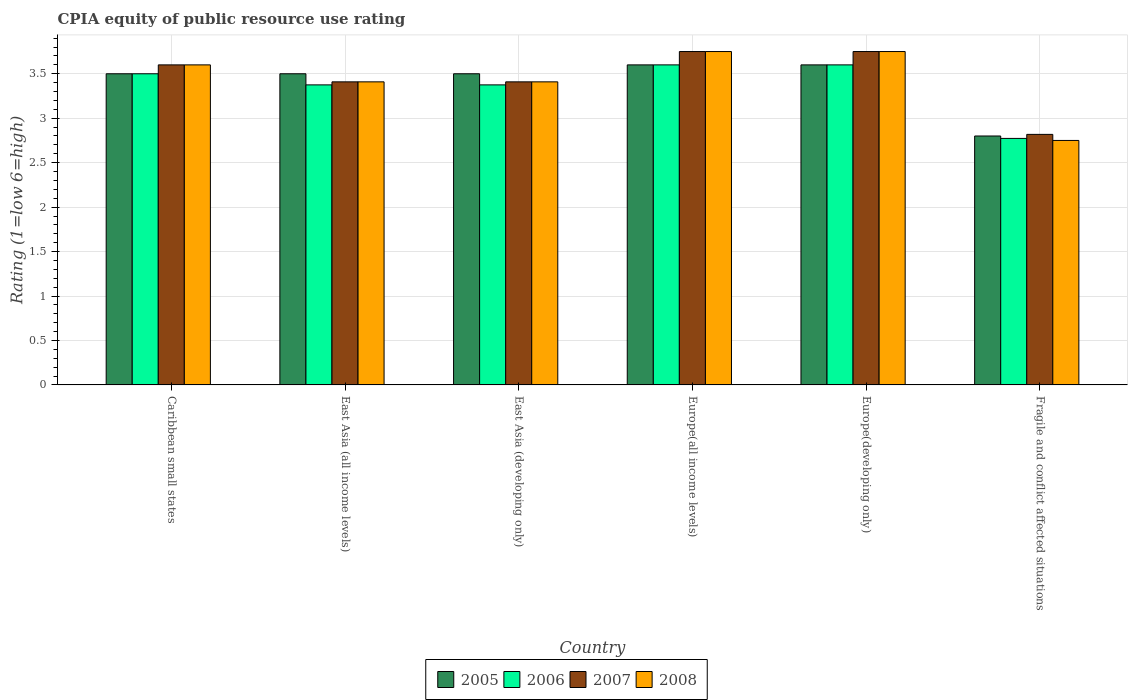How many different coloured bars are there?
Ensure brevity in your answer.  4. How many groups of bars are there?
Your answer should be compact. 6. What is the label of the 6th group of bars from the left?
Provide a succinct answer. Fragile and conflict affected situations. What is the CPIA rating in 2006 in Europe(all income levels)?
Your answer should be compact. 3.6. Across all countries, what is the maximum CPIA rating in 2008?
Your answer should be very brief. 3.75. In which country was the CPIA rating in 2007 maximum?
Your response must be concise. Europe(all income levels). In which country was the CPIA rating in 2007 minimum?
Your answer should be compact. Fragile and conflict affected situations. What is the total CPIA rating in 2008 in the graph?
Keep it short and to the point. 20.67. What is the difference between the CPIA rating in 2008 in Caribbean small states and that in Fragile and conflict affected situations?
Offer a terse response. 0.85. What is the difference between the CPIA rating in 2008 in Caribbean small states and the CPIA rating in 2006 in Europe(all income levels)?
Your answer should be compact. 0. What is the average CPIA rating in 2007 per country?
Make the answer very short. 3.46. What is the difference between the CPIA rating of/in 2005 and CPIA rating of/in 2007 in Europe(developing only)?
Make the answer very short. -0.15. What is the ratio of the CPIA rating in 2006 in Europe(developing only) to that in Fragile and conflict affected situations?
Offer a terse response. 1.3. Is the difference between the CPIA rating in 2005 in Europe(all income levels) and Fragile and conflict affected situations greater than the difference between the CPIA rating in 2007 in Europe(all income levels) and Fragile and conflict affected situations?
Offer a terse response. No. What is the difference between the highest and the second highest CPIA rating in 2006?
Provide a succinct answer. -0.1. What is the difference between the highest and the lowest CPIA rating in 2005?
Provide a short and direct response. 0.8. What does the 4th bar from the right in East Asia (all income levels) represents?
Give a very brief answer. 2005. How many countries are there in the graph?
Your answer should be very brief. 6. What is the difference between two consecutive major ticks on the Y-axis?
Keep it short and to the point. 0.5. Are the values on the major ticks of Y-axis written in scientific E-notation?
Provide a short and direct response. No. Where does the legend appear in the graph?
Provide a succinct answer. Bottom center. What is the title of the graph?
Provide a succinct answer. CPIA equity of public resource use rating. Does "2013" appear as one of the legend labels in the graph?
Offer a very short reply. No. What is the label or title of the X-axis?
Ensure brevity in your answer.  Country. What is the label or title of the Y-axis?
Offer a terse response. Rating (1=low 6=high). What is the Rating (1=low 6=high) in 2008 in Caribbean small states?
Your answer should be very brief. 3.6. What is the Rating (1=low 6=high) of 2005 in East Asia (all income levels)?
Provide a short and direct response. 3.5. What is the Rating (1=low 6=high) of 2006 in East Asia (all income levels)?
Your response must be concise. 3.38. What is the Rating (1=low 6=high) of 2007 in East Asia (all income levels)?
Your answer should be very brief. 3.41. What is the Rating (1=low 6=high) in 2008 in East Asia (all income levels)?
Make the answer very short. 3.41. What is the Rating (1=low 6=high) of 2005 in East Asia (developing only)?
Your answer should be compact. 3.5. What is the Rating (1=low 6=high) of 2006 in East Asia (developing only)?
Offer a very short reply. 3.38. What is the Rating (1=low 6=high) of 2007 in East Asia (developing only)?
Your answer should be very brief. 3.41. What is the Rating (1=low 6=high) in 2008 in East Asia (developing only)?
Your answer should be very brief. 3.41. What is the Rating (1=low 6=high) in 2007 in Europe(all income levels)?
Keep it short and to the point. 3.75. What is the Rating (1=low 6=high) of 2008 in Europe(all income levels)?
Your answer should be very brief. 3.75. What is the Rating (1=low 6=high) of 2006 in Europe(developing only)?
Give a very brief answer. 3.6. What is the Rating (1=low 6=high) in 2007 in Europe(developing only)?
Provide a succinct answer. 3.75. What is the Rating (1=low 6=high) in 2008 in Europe(developing only)?
Your response must be concise. 3.75. What is the Rating (1=low 6=high) in 2006 in Fragile and conflict affected situations?
Your answer should be very brief. 2.77. What is the Rating (1=low 6=high) of 2007 in Fragile and conflict affected situations?
Ensure brevity in your answer.  2.82. What is the Rating (1=low 6=high) of 2008 in Fragile and conflict affected situations?
Make the answer very short. 2.75. Across all countries, what is the maximum Rating (1=low 6=high) in 2005?
Your answer should be very brief. 3.6. Across all countries, what is the maximum Rating (1=low 6=high) in 2007?
Offer a terse response. 3.75. Across all countries, what is the maximum Rating (1=low 6=high) in 2008?
Offer a very short reply. 3.75. Across all countries, what is the minimum Rating (1=low 6=high) of 2006?
Ensure brevity in your answer.  2.77. Across all countries, what is the minimum Rating (1=low 6=high) of 2007?
Keep it short and to the point. 2.82. Across all countries, what is the minimum Rating (1=low 6=high) of 2008?
Offer a terse response. 2.75. What is the total Rating (1=low 6=high) in 2005 in the graph?
Your answer should be compact. 20.5. What is the total Rating (1=low 6=high) in 2006 in the graph?
Your response must be concise. 20.22. What is the total Rating (1=low 6=high) of 2007 in the graph?
Make the answer very short. 20.74. What is the total Rating (1=low 6=high) in 2008 in the graph?
Provide a succinct answer. 20.67. What is the difference between the Rating (1=low 6=high) in 2005 in Caribbean small states and that in East Asia (all income levels)?
Your response must be concise. 0. What is the difference between the Rating (1=low 6=high) in 2007 in Caribbean small states and that in East Asia (all income levels)?
Offer a terse response. 0.19. What is the difference between the Rating (1=low 6=high) in 2008 in Caribbean small states and that in East Asia (all income levels)?
Provide a short and direct response. 0.19. What is the difference between the Rating (1=low 6=high) of 2005 in Caribbean small states and that in East Asia (developing only)?
Provide a short and direct response. 0. What is the difference between the Rating (1=low 6=high) in 2006 in Caribbean small states and that in East Asia (developing only)?
Give a very brief answer. 0.12. What is the difference between the Rating (1=low 6=high) of 2007 in Caribbean small states and that in East Asia (developing only)?
Offer a very short reply. 0.19. What is the difference between the Rating (1=low 6=high) in 2008 in Caribbean small states and that in East Asia (developing only)?
Provide a short and direct response. 0.19. What is the difference between the Rating (1=low 6=high) in 2006 in Caribbean small states and that in Europe(all income levels)?
Provide a short and direct response. -0.1. What is the difference between the Rating (1=low 6=high) in 2006 in Caribbean small states and that in Europe(developing only)?
Offer a terse response. -0.1. What is the difference between the Rating (1=low 6=high) of 2007 in Caribbean small states and that in Europe(developing only)?
Make the answer very short. -0.15. What is the difference between the Rating (1=low 6=high) in 2006 in Caribbean small states and that in Fragile and conflict affected situations?
Provide a succinct answer. 0.73. What is the difference between the Rating (1=low 6=high) in 2007 in Caribbean small states and that in Fragile and conflict affected situations?
Provide a short and direct response. 0.78. What is the difference between the Rating (1=low 6=high) in 2008 in Caribbean small states and that in Fragile and conflict affected situations?
Your answer should be very brief. 0.85. What is the difference between the Rating (1=low 6=high) in 2005 in East Asia (all income levels) and that in East Asia (developing only)?
Provide a short and direct response. 0. What is the difference between the Rating (1=low 6=high) in 2007 in East Asia (all income levels) and that in East Asia (developing only)?
Ensure brevity in your answer.  0. What is the difference between the Rating (1=low 6=high) in 2006 in East Asia (all income levels) and that in Europe(all income levels)?
Provide a succinct answer. -0.23. What is the difference between the Rating (1=low 6=high) of 2007 in East Asia (all income levels) and that in Europe(all income levels)?
Offer a terse response. -0.34. What is the difference between the Rating (1=low 6=high) in 2008 in East Asia (all income levels) and that in Europe(all income levels)?
Keep it short and to the point. -0.34. What is the difference between the Rating (1=low 6=high) of 2006 in East Asia (all income levels) and that in Europe(developing only)?
Ensure brevity in your answer.  -0.23. What is the difference between the Rating (1=low 6=high) of 2007 in East Asia (all income levels) and that in Europe(developing only)?
Offer a very short reply. -0.34. What is the difference between the Rating (1=low 6=high) in 2008 in East Asia (all income levels) and that in Europe(developing only)?
Offer a very short reply. -0.34. What is the difference between the Rating (1=low 6=high) in 2005 in East Asia (all income levels) and that in Fragile and conflict affected situations?
Keep it short and to the point. 0.7. What is the difference between the Rating (1=low 6=high) in 2006 in East Asia (all income levels) and that in Fragile and conflict affected situations?
Make the answer very short. 0.6. What is the difference between the Rating (1=low 6=high) in 2007 in East Asia (all income levels) and that in Fragile and conflict affected situations?
Keep it short and to the point. 0.59. What is the difference between the Rating (1=low 6=high) of 2008 in East Asia (all income levels) and that in Fragile and conflict affected situations?
Provide a succinct answer. 0.66. What is the difference between the Rating (1=low 6=high) in 2005 in East Asia (developing only) and that in Europe(all income levels)?
Offer a terse response. -0.1. What is the difference between the Rating (1=low 6=high) in 2006 in East Asia (developing only) and that in Europe(all income levels)?
Ensure brevity in your answer.  -0.23. What is the difference between the Rating (1=low 6=high) of 2007 in East Asia (developing only) and that in Europe(all income levels)?
Offer a very short reply. -0.34. What is the difference between the Rating (1=low 6=high) in 2008 in East Asia (developing only) and that in Europe(all income levels)?
Offer a very short reply. -0.34. What is the difference between the Rating (1=low 6=high) in 2006 in East Asia (developing only) and that in Europe(developing only)?
Provide a short and direct response. -0.23. What is the difference between the Rating (1=low 6=high) of 2007 in East Asia (developing only) and that in Europe(developing only)?
Give a very brief answer. -0.34. What is the difference between the Rating (1=low 6=high) in 2008 in East Asia (developing only) and that in Europe(developing only)?
Keep it short and to the point. -0.34. What is the difference between the Rating (1=low 6=high) in 2005 in East Asia (developing only) and that in Fragile and conflict affected situations?
Your response must be concise. 0.7. What is the difference between the Rating (1=low 6=high) of 2006 in East Asia (developing only) and that in Fragile and conflict affected situations?
Give a very brief answer. 0.6. What is the difference between the Rating (1=low 6=high) in 2007 in East Asia (developing only) and that in Fragile and conflict affected situations?
Offer a very short reply. 0.59. What is the difference between the Rating (1=low 6=high) of 2008 in East Asia (developing only) and that in Fragile and conflict affected situations?
Provide a succinct answer. 0.66. What is the difference between the Rating (1=low 6=high) in 2005 in Europe(all income levels) and that in Europe(developing only)?
Give a very brief answer. 0. What is the difference between the Rating (1=low 6=high) in 2006 in Europe(all income levels) and that in Europe(developing only)?
Keep it short and to the point. 0. What is the difference between the Rating (1=low 6=high) in 2007 in Europe(all income levels) and that in Europe(developing only)?
Provide a short and direct response. 0. What is the difference between the Rating (1=low 6=high) in 2008 in Europe(all income levels) and that in Europe(developing only)?
Your answer should be compact. 0. What is the difference between the Rating (1=low 6=high) in 2006 in Europe(all income levels) and that in Fragile and conflict affected situations?
Provide a short and direct response. 0.83. What is the difference between the Rating (1=low 6=high) in 2007 in Europe(all income levels) and that in Fragile and conflict affected situations?
Provide a succinct answer. 0.93. What is the difference between the Rating (1=low 6=high) in 2008 in Europe(all income levels) and that in Fragile and conflict affected situations?
Keep it short and to the point. 1. What is the difference between the Rating (1=low 6=high) of 2005 in Europe(developing only) and that in Fragile and conflict affected situations?
Offer a very short reply. 0.8. What is the difference between the Rating (1=low 6=high) in 2006 in Europe(developing only) and that in Fragile and conflict affected situations?
Ensure brevity in your answer.  0.83. What is the difference between the Rating (1=low 6=high) of 2007 in Europe(developing only) and that in Fragile and conflict affected situations?
Offer a very short reply. 0.93. What is the difference between the Rating (1=low 6=high) of 2008 in Europe(developing only) and that in Fragile and conflict affected situations?
Keep it short and to the point. 1. What is the difference between the Rating (1=low 6=high) of 2005 in Caribbean small states and the Rating (1=low 6=high) of 2007 in East Asia (all income levels)?
Ensure brevity in your answer.  0.09. What is the difference between the Rating (1=low 6=high) in 2005 in Caribbean small states and the Rating (1=low 6=high) in 2008 in East Asia (all income levels)?
Offer a very short reply. 0.09. What is the difference between the Rating (1=low 6=high) in 2006 in Caribbean small states and the Rating (1=low 6=high) in 2007 in East Asia (all income levels)?
Ensure brevity in your answer.  0.09. What is the difference between the Rating (1=low 6=high) in 2006 in Caribbean small states and the Rating (1=low 6=high) in 2008 in East Asia (all income levels)?
Your answer should be compact. 0.09. What is the difference between the Rating (1=low 6=high) of 2007 in Caribbean small states and the Rating (1=low 6=high) of 2008 in East Asia (all income levels)?
Ensure brevity in your answer.  0.19. What is the difference between the Rating (1=low 6=high) of 2005 in Caribbean small states and the Rating (1=low 6=high) of 2006 in East Asia (developing only)?
Offer a terse response. 0.12. What is the difference between the Rating (1=low 6=high) in 2005 in Caribbean small states and the Rating (1=low 6=high) in 2007 in East Asia (developing only)?
Your response must be concise. 0.09. What is the difference between the Rating (1=low 6=high) of 2005 in Caribbean small states and the Rating (1=low 6=high) of 2008 in East Asia (developing only)?
Offer a very short reply. 0.09. What is the difference between the Rating (1=low 6=high) in 2006 in Caribbean small states and the Rating (1=low 6=high) in 2007 in East Asia (developing only)?
Provide a short and direct response. 0.09. What is the difference between the Rating (1=low 6=high) in 2006 in Caribbean small states and the Rating (1=low 6=high) in 2008 in East Asia (developing only)?
Make the answer very short. 0.09. What is the difference between the Rating (1=low 6=high) of 2007 in Caribbean small states and the Rating (1=low 6=high) of 2008 in East Asia (developing only)?
Keep it short and to the point. 0.19. What is the difference between the Rating (1=low 6=high) in 2005 in Caribbean small states and the Rating (1=low 6=high) in 2007 in Europe(all income levels)?
Keep it short and to the point. -0.25. What is the difference between the Rating (1=low 6=high) of 2006 in Caribbean small states and the Rating (1=low 6=high) of 2007 in Europe(all income levels)?
Offer a very short reply. -0.25. What is the difference between the Rating (1=low 6=high) of 2007 in Caribbean small states and the Rating (1=low 6=high) of 2008 in Europe(all income levels)?
Your answer should be compact. -0.15. What is the difference between the Rating (1=low 6=high) of 2005 in Caribbean small states and the Rating (1=low 6=high) of 2007 in Europe(developing only)?
Your answer should be compact. -0.25. What is the difference between the Rating (1=low 6=high) in 2005 in Caribbean small states and the Rating (1=low 6=high) in 2008 in Europe(developing only)?
Keep it short and to the point. -0.25. What is the difference between the Rating (1=low 6=high) of 2006 in Caribbean small states and the Rating (1=low 6=high) of 2008 in Europe(developing only)?
Ensure brevity in your answer.  -0.25. What is the difference between the Rating (1=low 6=high) of 2005 in Caribbean small states and the Rating (1=low 6=high) of 2006 in Fragile and conflict affected situations?
Provide a short and direct response. 0.73. What is the difference between the Rating (1=low 6=high) in 2005 in Caribbean small states and the Rating (1=low 6=high) in 2007 in Fragile and conflict affected situations?
Your answer should be very brief. 0.68. What is the difference between the Rating (1=low 6=high) of 2006 in Caribbean small states and the Rating (1=low 6=high) of 2007 in Fragile and conflict affected situations?
Your answer should be compact. 0.68. What is the difference between the Rating (1=low 6=high) in 2006 in Caribbean small states and the Rating (1=low 6=high) in 2008 in Fragile and conflict affected situations?
Offer a very short reply. 0.75. What is the difference between the Rating (1=low 6=high) of 2007 in Caribbean small states and the Rating (1=low 6=high) of 2008 in Fragile and conflict affected situations?
Provide a succinct answer. 0.85. What is the difference between the Rating (1=low 6=high) in 2005 in East Asia (all income levels) and the Rating (1=low 6=high) in 2007 in East Asia (developing only)?
Offer a very short reply. 0.09. What is the difference between the Rating (1=low 6=high) of 2005 in East Asia (all income levels) and the Rating (1=low 6=high) of 2008 in East Asia (developing only)?
Your answer should be compact. 0.09. What is the difference between the Rating (1=low 6=high) of 2006 in East Asia (all income levels) and the Rating (1=low 6=high) of 2007 in East Asia (developing only)?
Your answer should be very brief. -0.03. What is the difference between the Rating (1=low 6=high) in 2006 in East Asia (all income levels) and the Rating (1=low 6=high) in 2008 in East Asia (developing only)?
Offer a terse response. -0.03. What is the difference between the Rating (1=low 6=high) in 2007 in East Asia (all income levels) and the Rating (1=low 6=high) in 2008 in East Asia (developing only)?
Your answer should be compact. 0. What is the difference between the Rating (1=low 6=high) in 2005 in East Asia (all income levels) and the Rating (1=low 6=high) in 2008 in Europe(all income levels)?
Offer a very short reply. -0.25. What is the difference between the Rating (1=low 6=high) in 2006 in East Asia (all income levels) and the Rating (1=low 6=high) in 2007 in Europe(all income levels)?
Keep it short and to the point. -0.38. What is the difference between the Rating (1=low 6=high) of 2006 in East Asia (all income levels) and the Rating (1=low 6=high) of 2008 in Europe(all income levels)?
Make the answer very short. -0.38. What is the difference between the Rating (1=low 6=high) of 2007 in East Asia (all income levels) and the Rating (1=low 6=high) of 2008 in Europe(all income levels)?
Ensure brevity in your answer.  -0.34. What is the difference between the Rating (1=low 6=high) in 2005 in East Asia (all income levels) and the Rating (1=low 6=high) in 2007 in Europe(developing only)?
Provide a succinct answer. -0.25. What is the difference between the Rating (1=low 6=high) of 2006 in East Asia (all income levels) and the Rating (1=low 6=high) of 2007 in Europe(developing only)?
Offer a very short reply. -0.38. What is the difference between the Rating (1=low 6=high) of 2006 in East Asia (all income levels) and the Rating (1=low 6=high) of 2008 in Europe(developing only)?
Keep it short and to the point. -0.38. What is the difference between the Rating (1=low 6=high) of 2007 in East Asia (all income levels) and the Rating (1=low 6=high) of 2008 in Europe(developing only)?
Your answer should be compact. -0.34. What is the difference between the Rating (1=low 6=high) in 2005 in East Asia (all income levels) and the Rating (1=low 6=high) in 2006 in Fragile and conflict affected situations?
Provide a succinct answer. 0.73. What is the difference between the Rating (1=low 6=high) in 2005 in East Asia (all income levels) and the Rating (1=low 6=high) in 2007 in Fragile and conflict affected situations?
Provide a short and direct response. 0.68. What is the difference between the Rating (1=low 6=high) in 2006 in East Asia (all income levels) and the Rating (1=low 6=high) in 2007 in Fragile and conflict affected situations?
Ensure brevity in your answer.  0.56. What is the difference between the Rating (1=low 6=high) of 2006 in East Asia (all income levels) and the Rating (1=low 6=high) of 2008 in Fragile and conflict affected situations?
Provide a succinct answer. 0.62. What is the difference between the Rating (1=low 6=high) in 2007 in East Asia (all income levels) and the Rating (1=low 6=high) in 2008 in Fragile and conflict affected situations?
Provide a short and direct response. 0.66. What is the difference between the Rating (1=low 6=high) in 2005 in East Asia (developing only) and the Rating (1=low 6=high) in 2007 in Europe(all income levels)?
Provide a succinct answer. -0.25. What is the difference between the Rating (1=low 6=high) of 2006 in East Asia (developing only) and the Rating (1=low 6=high) of 2007 in Europe(all income levels)?
Keep it short and to the point. -0.38. What is the difference between the Rating (1=low 6=high) of 2006 in East Asia (developing only) and the Rating (1=low 6=high) of 2008 in Europe(all income levels)?
Your answer should be very brief. -0.38. What is the difference between the Rating (1=low 6=high) of 2007 in East Asia (developing only) and the Rating (1=low 6=high) of 2008 in Europe(all income levels)?
Give a very brief answer. -0.34. What is the difference between the Rating (1=low 6=high) of 2005 in East Asia (developing only) and the Rating (1=low 6=high) of 2007 in Europe(developing only)?
Your answer should be very brief. -0.25. What is the difference between the Rating (1=low 6=high) of 2005 in East Asia (developing only) and the Rating (1=low 6=high) of 2008 in Europe(developing only)?
Provide a short and direct response. -0.25. What is the difference between the Rating (1=low 6=high) in 2006 in East Asia (developing only) and the Rating (1=low 6=high) in 2007 in Europe(developing only)?
Ensure brevity in your answer.  -0.38. What is the difference between the Rating (1=low 6=high) of 2006 in East Asia (developing only) and the Rating (1=low 6=high) of 2008 in Europe(developing only)?
Offer a very short reply. -0.38. What is the difference between the Rating (1=low 6=high) of 2007 in East Asia (developing only) and the Rating (1=low 6=high) of 2008 in Europe(developing only)?
Provide a short and direct response. -0.34. What is the difference between the Rating (1=low 6=high) of 2005 in East Asia (developing only) and the Rating (1=low 6=high) of 2006 in Fragile and conflict affected situations?
Ensure brevity in your answer.  0.73. What is the difference between the Rating (1=low 6=high) of 2005 in East Asia (developing only) and the Rating (1=low 6=high) of 2007 in Fragile and conflict affected situations?
Provide a short and direct response. 0.68. What is the difference between the Rating (1=low 6=high) in 2006 in East Asia (developing only) and the Rating (1=low 6=high) in 2007 in Fragile and conflict affected situations?
Keep it short and to the point. 0.56. What is the difference between the Rating (1=low 6=high) of 2006 in East Asia (developing only) and the Rating (1=low 6=high) of 2008 in Fragile and conflict affected situations?
Your response must be concise. 0.62. What is the difference between the Rating (1=low 6=high) of 2007 in East Asia (developing only) and the Rating (1=low 6=high) of 2008 in Fragile and conflict affected situations?
Keep it short and to the point. 0.66. What is the difference between the Rating (1=low 6=high) in 2005 in Europe(all income levels) and the Rating (1=low 6=high) in 2006 in Europe(developing only)?
Offer a very short reply. 0. What is the difference between the Rating (1=low 6=high) in 2005 in Europe(all income levels) and the Rating (1=low 6=high) in 2007 in Europe(developing only)?
Keep it short and to the point. -0.15. What is the difference between the Rating (1=low 6=high) in 2007 in Europe(all income levels) and the Rating (1=low 6=high) in 2008 in Europe(developing only)?
Provide a short and direct response. 0. What is the difference between the Rating (1=low 6=high) of 2005 in Europe(all income levels) and the Rating (1=low 6=high) of 2006 in Fragile and conflict affected situations?
Provide a succinct answer. 0.83. What is the difference between the Rating (1=low 6=high) of 2005 in Europe(all income levels) and the Rating (1=low 6=high) of 2007 in Fragile and conflict affected situations?
Keep it short and to the point. 0.78. What is the difference between the Rating (1=low 6=high) in 2006 in Europe(all income levels) and the Rating (1=low 6=high) in 2007 in Fragile and conflict affected situations?
Your answer should be very brief. 0.78. What is the difference between the Rating (1=low 6=high) in 2006 in Europe(all income levels) and the Rating (1=low 6=high) in 2008 in Fragile and conflict affected situations?
Offer a terse response. 0.85. What is the difference between the Rating (1=low 6=high) of 2005 in Europe(developing only) and the Rating (1=low 6=high) of 2006 in Fragile and conflict affected situations?
Offer a terse response. 0.83. What is the difference between the Rating (1=low 6=high) in 2005 in Europe(developing only) and the Rating (1=low 6=high) in 2007 in Fragile and conflict affected situations?
Keep it short and to the point. 0.78. What is the difference between the Rating (1=low 6=high) of 2006 in Europe(developing only) and the Rating (1=low 6=high) of 2007 in Fragile and conflict affected situations?
Give a very brief answer. 0.78. What is the difference between the Rating (1=low 6=high) of 2006 in Europe(developing only) and the Rating (1=low 6=high) of 2008 in Fragile and conflict affected situations?
Keep it short and to the point. 0.85. What is the average Rating (1=low 6=high) in 2005 per country?
Your answer should be very brief. 3.42. What is the average Rating (1=low 6=high) of 2006 per country?
Provide a short and direct response. 3.37. What is the average Rating (1=low 6=high) in 2007 per country?
Your response must be concise. 3.46. What is the average Rating (1=low 6=high) in 2008 per country?
Provide a succinct answer. 3.44. What is the difference between the Rating (1=low 6=high) in 2005 and Rating (1=low 6=high) in 2008 in Caribbean small states?
Offer a very short reply. -0.1. What is the difference between the Rating (1=low 6=high) of 2005 and Rating (1=low 6=high) of 2006 in East Asia (all income levels)?
Your answer should be compact. 0.12. What is the difference between the Rating (1=low 6=high) in 2005 and Rating (1=low 6=high) in 2007 in East Asia (all income levels)?
Give a very brief answer. 0.09. What is the difference between the Rating (1=low 6=high) in 2005 and Rating (1=low 6=high) in 2008 in East Asia (all income levels)?
Provide a short and direct response. 0.09. What is the difference between the Rating (1=low 6=high) in 2006 and Rating (1=low 6=high) in 2007 in East Asia (all income levels)?
Offer a terse response. -0.03. What is the difference between the Rating (1=low 6=high) of 2006 and Rating (1=low 6=high) of 2008 in East Asia (all income levels)?
Keep it short and to the point. -0.03. What is the difference between the Rating (1=low 6=high) in 2007 and Rating (1=low 6=high) in 2008 in East Asia (all income levels)?
Your answer should be compact. 0. What is the difference between the Rating (1=low 6=high) in 2005 and Rating (1=low 6=high) in 2007 in East Asia (developing only)?
Your answer should be compact. 0.09. What is the difference between the Rating (1=low 6=high) of 2005 and Rating (1=low 6=high) of 2008 in East Asia (developing only)?
Provide a succinct answer. 0.09. What is the difference between the Rating (1=low 6=high) of 2006 and Rating (1=low 6=high) of 2007 in East Asia (developing only)?
Offer a terse response. -0.03. What is the difference between the Rating (1=low 6=high) in 2006 and Rating (1=low 6=high) in 2008 in East Asia (developing only)?
Make the answer very short. -0.03. What is the difference between the Rating (1=low 6=high) of 2007 and Rating (1=low 6=high) of 2008 in East Asia (developing only)?
Your answer should be compact. 0. What is the difference between the Rating (1=low 6=high) of 2005 and Rating (1=low 6=high) of 2006 in Europe(all income levels)?
Keep it short and to the point. 0. What is the difference between the Rating (1=low 6=high) of 2005 and Rating (1=low 6=high) of 2008 in Europe(all income levels)?
Your response must be concise. -0.15. What is the difference between the Rating (1=low 6=high) of 2005 and Rating (1=low 6=high) of 2007 in Europe(developing only)?
Provide a short and direct response. -0.15. What is the difference between the Rating (1=low 6=high) in 2005 and Rating (1=low 6=high) in 2008 in Europe(developing only)?
Provide a short and direct response. -0.15. What is the difference between the Rating (1=low 6=high) of 2006 and Rating (1=low 6=high) of 2007 in Europe(developing only)?
Give a very brief answer. -0.15. What is the difference between the Rating (1=low 6=high) in 2006 and Rating (1=low 6=high) in 2008 in Europe(developing only)?
Offer a very short reply. -0.15. What is the difference between the Rating (1=low 6=high) in 2005 and Rating (1=low 6=high) in 2006 in Fragile and conflict affected situations?
Your answer should be compact. 0.03. What is the difference between the Rating (1=low 6=high) in 2005 and Rating (1=low 6=high) in 2007 in Fragile and conflict affected situations?
Give a very brief answer. -0.02. What is the difference between the Rating (1=low 6=high) of 2005 and Rating (1=low 6=high) of 2008 in Fragile and conflict affected situations?
Offer a terse response. 0.05. What is the difference between the Rating (1=low 6=high) of 2006 and Rating (1=low 6=high) of 2007 in Fragile and conflict affected situations?
Provide a short and direct response. -0.05. What is the difference between the Rating (1=low 6=high) of 2006 and Rating (1=low 6=high) of 2008 in Fragile and conflict affected situations?
Give a very brief answer. 0.02. What is the difference between the Rating (1=low 6=high) in 2007 and Rating (1=low 6=high) in 2008 in Fragile and conflict affected situations?
Provide a short and direct response. 0.07. What is the ratio of the Rating (1=low 6=high) in 2006 in Caribbean small states to that in East Asia (all income levels)?
Give a very brief answer. 1.04. What is the ratio of the Rating (1=low 6=high) in 2007 in Caribbean small states to that in East Asia (all income levels)?
Make the answer very short. 1.06. What is the ratio of the Rating (1=low 6=high) in 2008 in Caribbean small states to that in East Asia (all income levels)?
Make the answer very short. 1.06. What is the ratio of the Rating (1=low 6=high) in 2005 in Caribbean small states to that in East Asia (developing only)?
Your answer should be very brief. 1. What is the ratio of the Rating (1=low 6=high) in 2006 in Caribbean small states to that in East Asia (developing only)?
Provide a short and direct response. 1.04. What is the ratio of the Rating (1=low 6=high) of 2007 in Caribbean small states to that in East Asia (developing only)?
Your answer should be compact. 1.06. What is the ratio of the Rating (1=low 6=high) of 2008 in Caribbean small states to that in East Asia (developing only)?
Your response must be concise. 1.06. What is the ratio of the Rating (1=low 6=high) in 2005 in Caribbean small states to that in Europe(all income levels)?
Ensure brevity in your answer.  0.97. What is the ratio of the Rating (1=low 6=high) in 2006 in Caribbean small states to that in Europe(all income levels)?
Your answer should be compact. 0.97. What is the ratio of the Rating (1=low 6=high) in 2008 in Caribbean small states to that in Europe(all income levels)?
Provide a succinct answer. 0.96. What is the ratio of the Rating (1=low 6=high) of 2005 in Caribbean small states to that in Europe(developing only)?
Your answer should be very brief. 0.97. What is the ratio of the Rating (1=low 6=high) of 2006 in Caribbean small states to that in Europe(developing only)?
Keep it short and to the point. 0.97. What is the ratio of the Rating (1=low 6=high) of 2007 in Caribbean small states to that in Europe(developing only)?
Ensure brevity in your answer.  0.96. What is the ratio of the Rating (1=low 6=high) of 2005 in Caribbean small states to that in Fragile and conflict affected situations?
Offer a terse response. 1.25. What is the ratio of the Rating (1=low 6=high) in 2006 in Caribbean small states to that in Fragile and conflict affected situations?
Your answer should be very brief. 1.26. What is the ratio of the Rating (1=low 6=high) of 2007 in Caribbean small states to that in Fragile and conflict affected situations?
Give a very brief answer. 1.28. What is the ratio of the Rating (1=low 6=high) in 2008 in Caribbean small states to that in Fragile and conflict affected situations?
Offer a terse response. 1.31. What is the ratio of the Rating (1=low 6=high) in 2007 in East Asia (all income levels) to that in East Asia (developing only)?
Make the answer very short. 1. What is the ratio of the Rating (1=low 6=high) of 2005 in East Asia (all income levels) to that in Europe(all income levels)?
Provide a short and direct response. 0.97. What is the ratio of the Rating (1=low 6=high) in 2007 in East Asia (all income levels) to that in Europe(all income levels)?
Offer a terse response. 0.91. What is the ratio of the Rating (1=low 6=high) in 2005 in East Asia (all income levels) to that in Europe(developing only)?
Keep it short and to the point. 0.97. What is the ratio of the Rating (1=low 6=high) in 2007 in East Asia (all income levels) to that in Europe(developing only)?
Your answer should be very brief. 0.91. What is the ratio of the Rating (1=low 6=high) in 2005 in East Asia (all income levels) to that in Fragile and conflict affected situations?
Make the answer very short. 1.25. What is the ratio of the Rating (1=low 6=high) in 2006 in East Asia (all income levels) to that in Fragile and conflict affected situations?
Provide a succinct answer. 1.22. What is the ratio of the Rating (1=low 6=high) in 2007 in East Asia (all income levels) to that in Fragile and conflict affected situations?
Offer a terse response. 1.21. What is the ratio of the Rating (1=low 6=high) of 2008 in East Asia (all income levels) to that in Fragile and conflict affected situations?
Provide a short and direct response. 1.24. What is the ratio of the Rating (1=low 6=high) in 2005 in East Asia (developing only) to that in Europe(all income levels)?
Ensure brevity in your answer.  0.97. What is the ratio of the Rating (1=low 6=high) of 2008 in East Asia (developing only) to that in Europe(all income levels)?
Offer a very short reply. 0.91. What is the ratio of the Rating (1=low 6=high) of 2005 in East Asia (developing only) to that in Europe(developing only)?
Provide a short and direct response. 0.97. What is the ratio of the Rating (1=low 6=high) in 2006 in East Asia (developing only) to that in Europe(developing only)?
Make the answer very short. 0.94. What is the ratio of the Rating (1=low 6=high) of 2008 in East Asia (developing only) to that in Europe(developing only)?
Your answer should be very brief. 0.91. What is the ratio of the Rating (1=low 6=high) in 2005 in East Asia (developing only) to that in Fragile and conflict affected situations?
Your response must be concise. 1.25. What is the ratio of the Rating (1=low 6=high) in 2006 in East Asia (developing only) to that in Fragile and conflict affected situations?
Your response must be concise. 1.22. What is the ratio of the Rating (1=low 6=high) in 2007 in East Asia (developing only) to that in Fragile and conflict affected situations?
Provide a short and direct response. 1.21. What is the ratio of the Rating (1=low 6=high) of 2008 in East Asia (developing only) to that in Fragile and conflict affected situations?
Your response must be concise. 1.24. What is the ratio of the Rating (1=low 6=high) of 2005 in Europe(all income levels) to that in Europe(developing only)?
Provide a succinct answer. 1. What is the ratio of the Rating (1=low 6=high) of 2006 in Europe(all income levels) to that in Europe(developing only)?
Provide a succinct answer. 1. What is the ratio of the Rating (1=low 6=high) in 2008 in Europe(all income levels) to that in Europe(developing only)?
Offer a terse response. 1. What is the ratio of the Rating (1=low 6=high) in 2005 in Europe(all income levels) to that in Fragile and conflict affected situations?
Keep it short and to the point. 1.29. What is the ratio of the Rating (1=low 6=high) in 2006 in Europe(all income levels) to that in Fragile and conflict affected situations?
Keep it short and to the point. 1.3. What is the ratio of the Rating (1=low 6=high) of 2007 in Europe(all income levels) to that in Fragile and conflict affected situations?
Keep it short and to the point. 1.33. What is the ratio of the Rating (1=low 6=high) of 2008 in Europe(all income levels) to that in Fragile and conflict affected situations?
Provide a short and direct response. 1.36. What is the ratio of the Rating (1=low 6=high) in 2005 in Europe(developing only) to that in Fragile and conflict affected situations?
Give a very brief answer. 1.29. What is the ratio of the Rating (1=low 6=high) in 2006 in Europe(developing only) to that in Fragile and conflict affected situations?
Give a very brief answer. 1.3. What is the ratio of the Rating (1=low 6=high) in 2007 in Europe(developing only) to that in Fragile and conflict affected situations?
Keep it short and to the point. 1.33. What is the ratio of the Rating (1=low 6=high) in 2008 in Europe(developing only) to that in Fragile and conflict affected situations?
Provide a succinct answer. 1.36. What is the difference between the highest and the second highest Rating (1=low 6=high) of 2006?
Make the answer very short. 0. What is the difference between the highest and the second highest Rating (1=low 6=high) in 2007?
Give a very brief answer. 0. What is the difference between the highest and the second highest Rating (1=low 6=high) of 2008?
Your answer should be very brief. 0. What is the difference between the highest and the lowest Rating (1=low 6=high) in 2006?
Provide a short and direct response. 0.83. What is the difference between the highest and the lowest Rating (1=low 6=high) in 2007?
Provide a short and direct response. 0.93. 